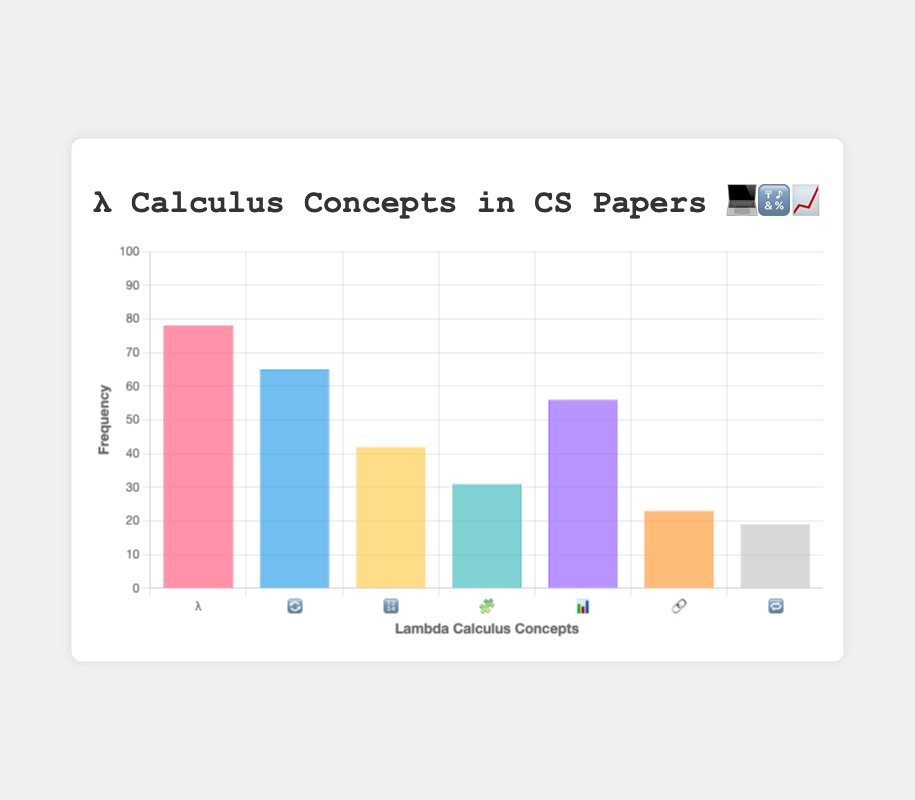Which lambda calculus concept has the highest frequency in CS papers? By reading the bars of the chart, the λ symbol representing "Lambda abstraction" is the tallest bar, indicating it has the highest frequency.
Answer: Lambda abstraction What is the frequency of the "Type theory" concept in CS papers? The bar representing "📊" stands for "Type theory," and its position on the frequency axis indicates a value of 56.
Answer: 56 How many more papers discuss "Beta reduction" compared to "Fixed-point combinator"? The frequencies of "Beta reduction" and "Fixed-point combinator" are 65 and 19, respectively. The difference is 65 - 19.
Answer: 46 What is the combined frequency of "Church encoding" and "Combinatory logic"? The frequency of "Church encoding" is 42, and for "Combinatory logic" is 31. The combined frequency is 42 + 31.
Answer: 73 Which concept has the lowest frequency and what is that frequency? The "🔁" symbol for "Fixed-point combinator" is the shortest bar, indicating the lowest frequency, which is 19.
Answer: Fixed-point combinator, 19 Compare the frequency of "Curry-Howard isomorphism" with "Type theory." Which one is higher? The frequency of "Curry-Howard isomorphism" is 23, and for "Type theory" is 56. Since 56 is greater than 23, "Type theory" is higher.
Answer: Type theory What's the average frequency of all the lambda calculus concepts? Sum the frequencies: 78 + 65 + 42 + 31 + 56 + 23 + 19 = 314. Divide by the number of concepts, which is 7. The average frequency is 314/7.
Answer: 44.86 Identify the second most discussed concept in the chart. The second tallest bar is the "🔄" symbol for "Beta reduction," which has a frequency of 65.
Answer: Beta reduction What are the frequencies of concepts represented by emojis 📊 and 🔢? The emoji "📊" (Type theory) has a frequency of 56, and "🔢" (Church encoding) has a frequency of 42.
Answer: 56, 42 